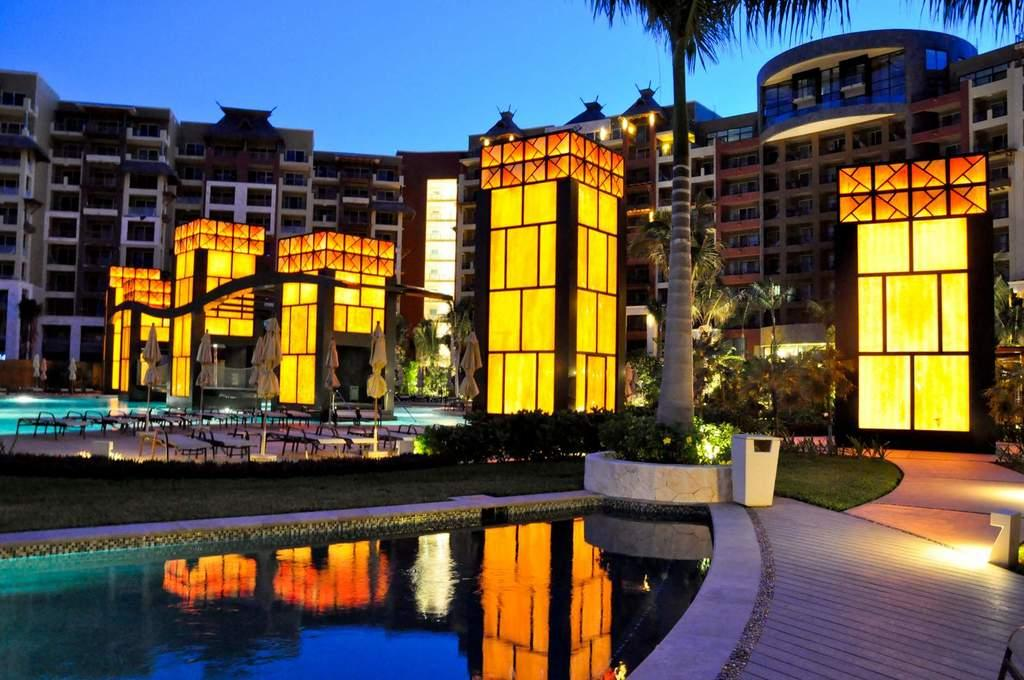What is the main feature in the image? There is a swimming pool in the image. What type of landscape is visible at the bottom side of the image? There is grassland at the bottom side of the image. What type of furniture can be seen in the background of the image? There are chairs, tables, and umbrellas in the background of the image. What type of structures are visible in the background of the image? There are buildings in the background of the image. What type of vegetation is visible in the background of the image? There are trees in the background of the image. What part of the natural environment is visible in the background of the image? The sky is visible in the background of the image. Can you see any matches being lit in the image? There are no matches or any indication of fire in the image. 